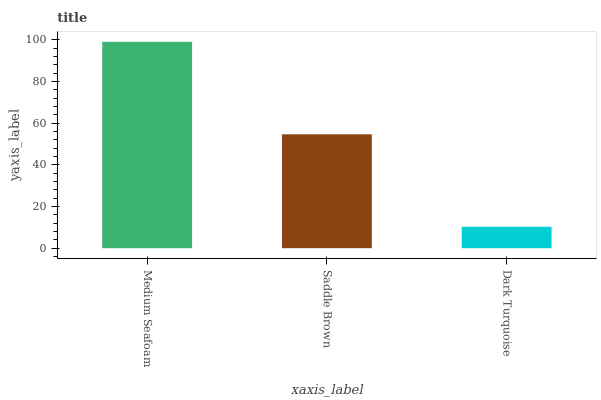Is Dark Turquoise the minimum?
Answer yes or no. Yes. Is Medium Seafoam the maximum?
Answer yes or no. Yes. Is Saddle Brown the minimum?
Answer yes or no. No. Is Saddle Brown the maximum?
Answer yes or no. No. Is Medium Seafoam greater than Saddle Brown?
Answer yes or no. Yes. Is Saddle Brown less than Medium Seafoam?
Answer yes or no. Yes. Is Saddle Brown greater than Medium Seafoam?
Answer yes or no. No. Is Medium Seafoam less than Saddle Brown?
Answer yes or no. No. Is Saddle Brown the high median?
Answer yes or no. Yes. Is Saddle Brown the low median?
Answer yes or no. Yes. Is Medium Seafoam the high median?
Answer yes or no. No. Is Dark Turquoise the low median?
Answer yes or no. No. 